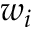<formula> <loc_0><loc_0><loc_500><loc_500>w _ { i }</formula> 